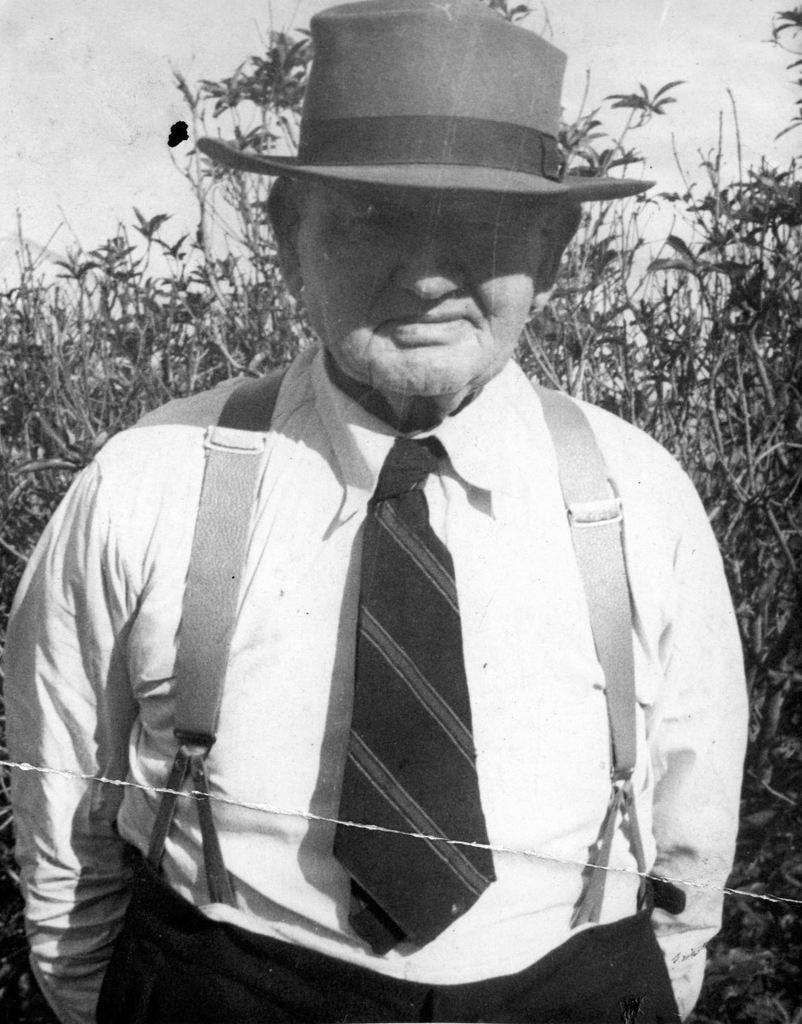What is the main subject of the image? There is a person standing in the center of the image. What can be seen in the background of the image? There are plants and the sky visible in the background of the image. What type of steel is being used to construct the system in the image? There is no system or steel present in the image; it features a person standing in the center with plants and the sky in the background. 